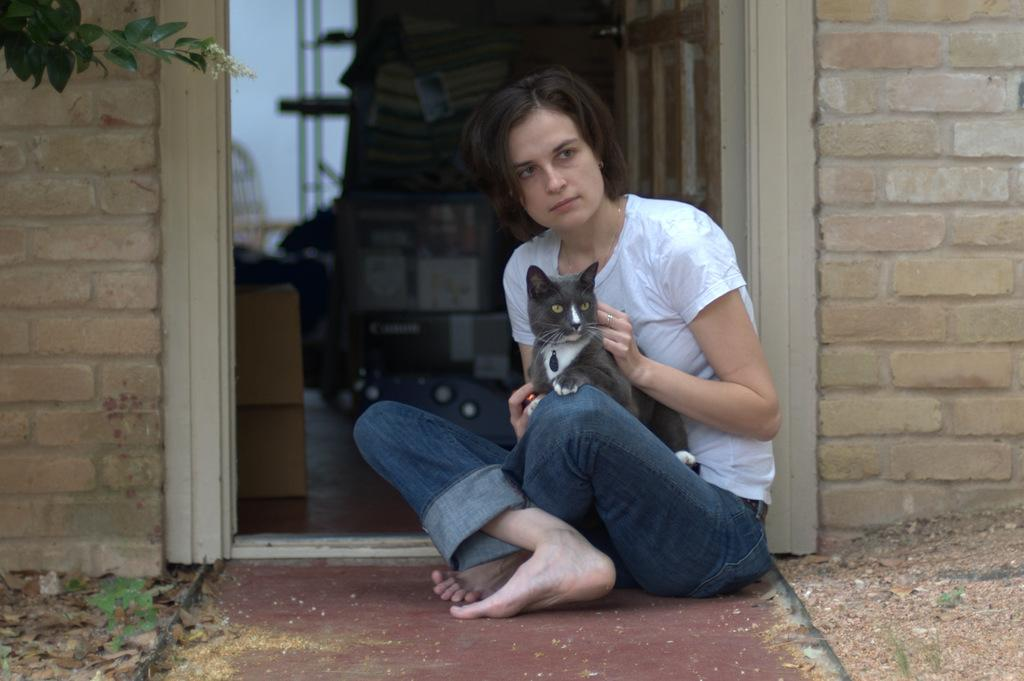Who is present in the image? There is a woman in the image. What is the woman doing in the image? The woman is seated on the floor. What is the woman holding in her hand? The woman is holding a cat in her hand. What type of structure can be seen in the image? There is a house in the image. What type of plant life is visible in the image? There is a tree in the image. Where is the slave located in the image? There is no slave present in the image. What type of animal can be seen grazing near the tree in the image? There are no animals visible in the image, including deer. 